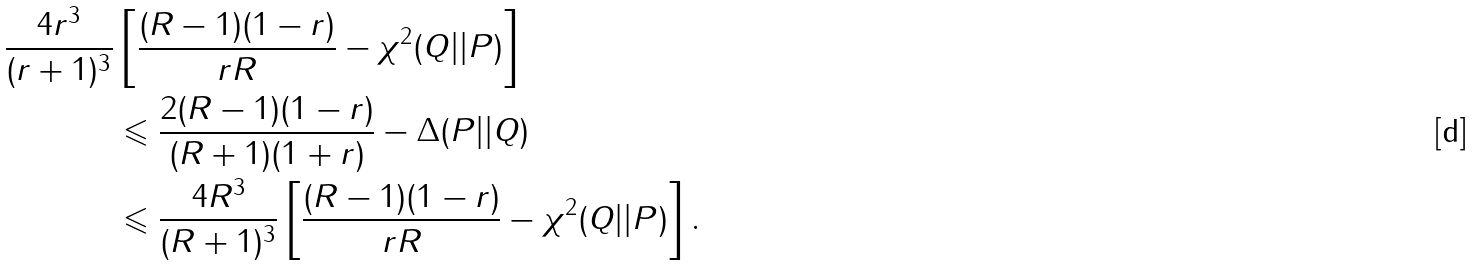Convert formula to latex. <formula><loc_0><loc_0><loc_500><loc_500>\frac { 4 r ^ { 3 } } { ( r + 1 ) ^ { 3 } } & \left [ { \frac { ( R - 1 ) ( 1 - r ) } { r R } - \chi ^ { 2 } ( Q | | P ) } \right ] \\ & \leqslant \frac { 2 ( R - 1 ) ( 1 - r ) } { ( R + 1 ) ( 1 + r ) } - \Delta ( P | | Q ) \\ & \leqslant \frac { 4 R ^ { 3 } } { ( R + 1 ) ^ { 3 } } \left [ { \frac { ( R - 1 ) ( 1 - r ) } { r R } - \chi ^ { 2 } ( Q | | P ) } \right ] .</formula> 